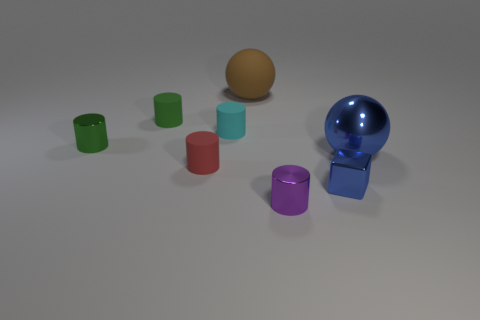Subtract all green cylinders. How many were subtracted if there are1green cylinders left? 1 Subtract all red cylinders. How many cylinders are left? 4 Subtract all tiny purple cylinders. How many cylinders are left? 4 Subtract all yellow cylinders. Subtract all brown cubes. How many cylinders are left? 5 Add 1 gray rubber cylinders. How many objects exist? 9 Subtract all balls. How many objects are left? 6 Subtract 1 purple cylinders. How many objects are left? 7 Subtract all small cyan metal objects. Subtract all brown rubber spheres. How many objects are left? 7 Add 6 tiny cyan objects. How many tiny cyan objects are left? 7 Add 2 big blue metal things. How many big blue metal things exist? 3 